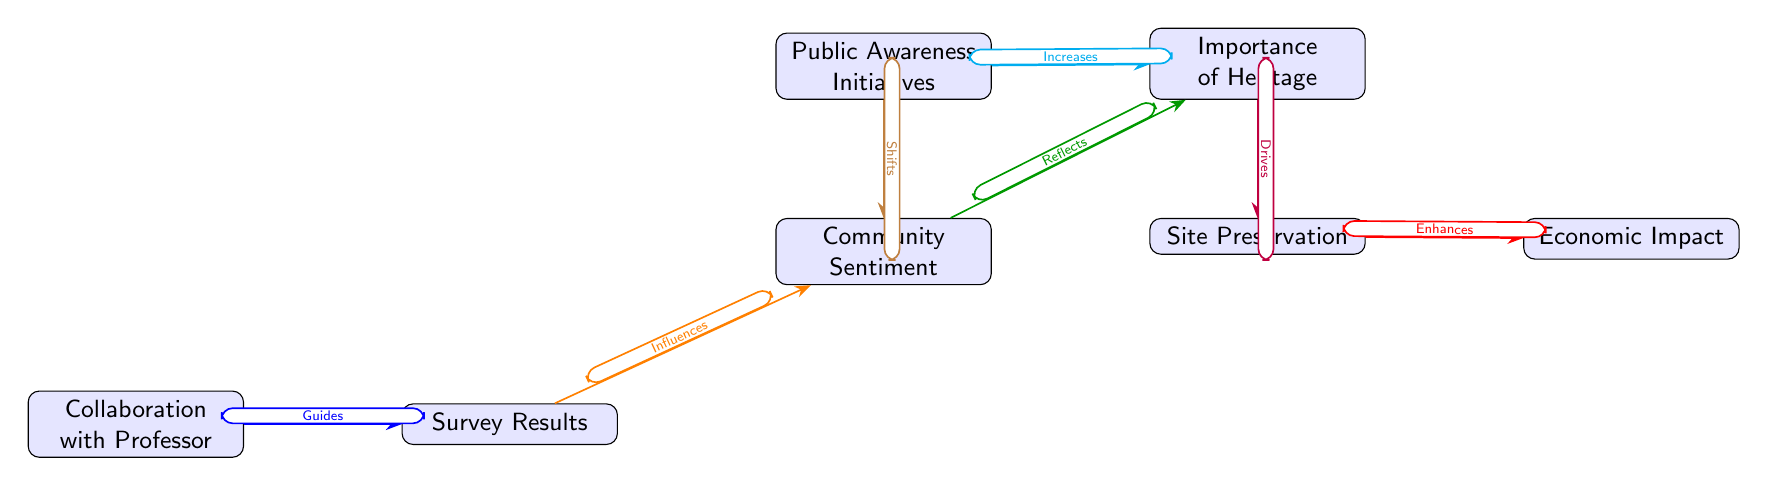What is the main focus of the diagram? The diagram primarily focuses on "Community Sentiment" as the central theme, indicating that the study revolves around understanding the community's feelings about aviation heritage sites.
Answer: Community Sentiment How many main nodes are present in the diagram? There are six main nodes (Community Sentiment, Importance of Heritage, Survey Results, Collaboration with Professor, Public Awareness Initiatives, Economic Impact, and Site Preservation).
Answer: Six What does "Survey Results" influence? According to the diagram, "Survey Results" influences "Community Sentiment," indicating that results from surveys impact how the community feels about the heritage sites.
Answer: Community Sentiment What relationship does "Importance of Heritage" have with "Site Preservation"? "Importance of Heritage" drives "Site Preservation," suggesting that recognizing the significance of heritage promotes preserving these sites.
Answer: Drives What increases the "Importance of Heritage"? The diagram states that "Public Awareness Initiatives" increase the "Importance of Heritage," indicating that raising awareness contributes positively to how the heritage sites are valued.
Answer: Increases How does "Collaboration with Professor" affect "Survey Results"? The relationship shows that "Collaboration with Professor" guides "Survey Results," meaning that working with the professor steers the outcomes of the surveys conducted.
Answer: Guides What enhances "Economic Impact"? The diagram indicates that "Site Preservation" enhances "Economic Impact," suggesting that preserving the aviation heritage sites positively influences the local economy.
Answer: Enhances What does "Public Awareness Initiatives" do to "Community Sentiment"? According to the diagram, "Public Awareness Initiatives" shift "Community Sentiment," reflecting a change in public opinion resulting from these initiatives.
Answer: Shifts What is the direct effect of survey results on community sentiment? The survey results directly influence community sentiment, meaning that the opinions gathered in surveys shape how the community feels about aviation heritage.
Answer: Influences 